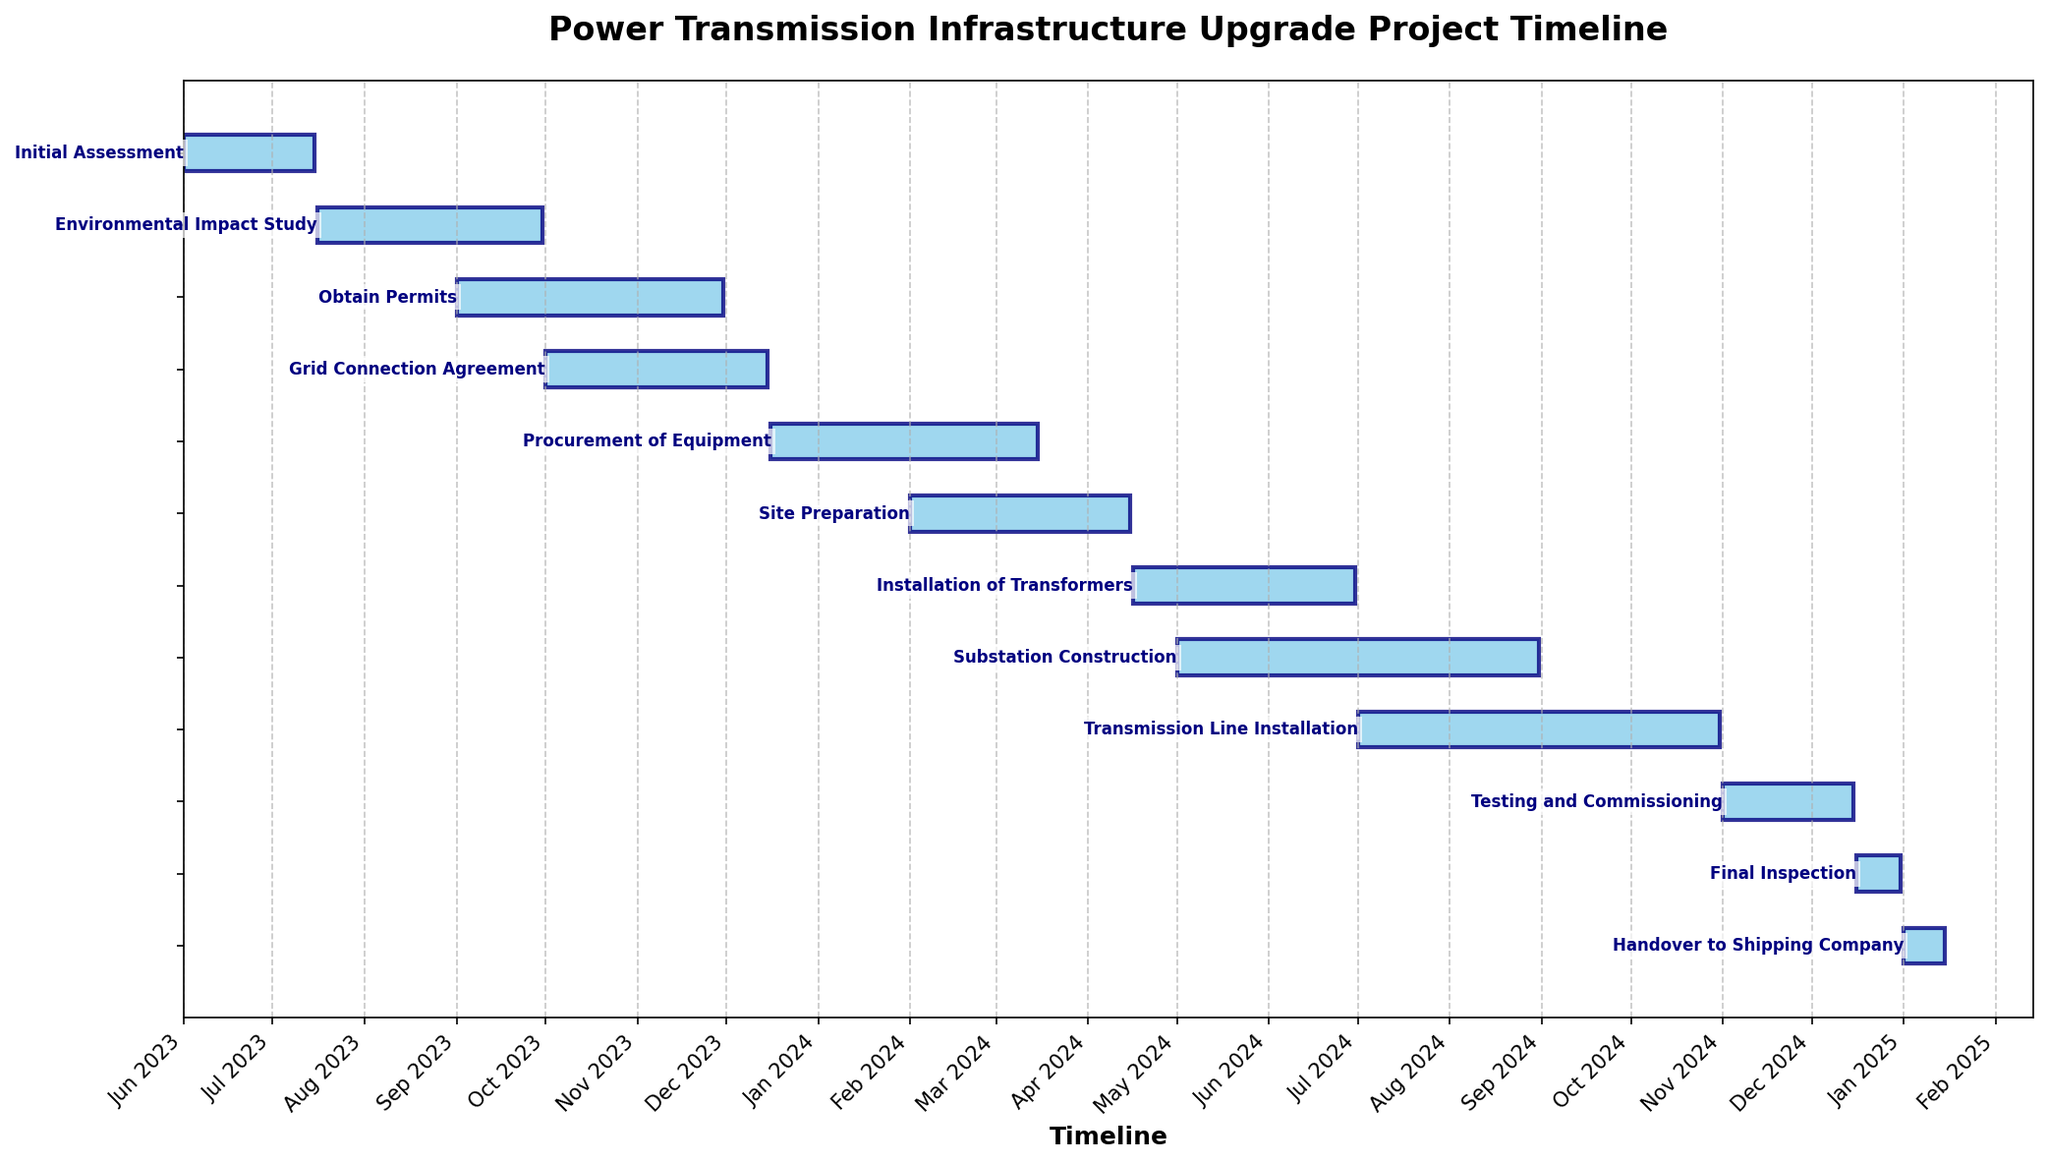What is the title of the Gantt Chart? Look at the top of the chart, where the title is usually located in larger, bold text.
Answer: Power Transmission Infrastructure Upgrade Project Timeline Which task has the shortest duration? Compare the lengths of all the bars, the shortest one represents the task with the shortest duration.
Answer: Final Inspection What is the start date of the project? Find the earliest date on the timeline axis, which corresponds to the start date of the first task.
Answer: June 1, 2023 What is the end date of the project? Find the latest date on the timeline axis, which corresponds to the end date of the last task.
Answer: January 15, 2025 How long is the Environmental Impact Study scheduled to last? The length of the bar for the Environmental Impact Study represents its duration. Look for this data visually or refer to the duration listed in the dataset.
Answer: 77 days Which tasks overlap with the "Grid Connection Agreement"? Identify the timeline range for the Grid Connection Agreement and check other tasks that have bars within this range.
Answer: Obtain Permits, Procurement of Equipment What is the total duration from the start of 'Site Preparation' to the end of 'Substation Construction'? Find the start date of 'Site Preparation' and the end date of 'Substation Construction' and calculate the difference between them.
Answer: 212 days Which task has the longest duration, and how long is it? Measure the lengths of all tasks' bars and identify the longest one.
Answer: Substation Construction, 123 days Do 'Transmission Line Installation' and 'Testing and Commissioning' overlap in the timeline? Check if the timeline bars of 'Transmission Line Installation' and 'Testing and Commissioning' intersect.
Answer: No 